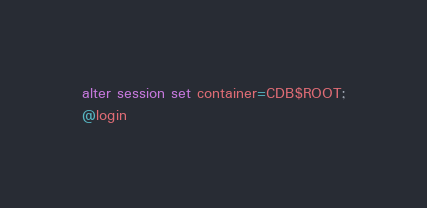Convert code to text. <code><loc_0><loc_0><loc_500><loc_500><_SQL_>alter session set container=CDB$ROOT;
@login
</code> 